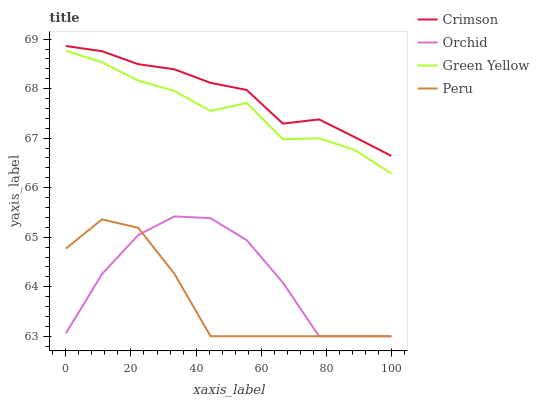Does Peru have the minimum area under the curve?
Answer yes or no. Yes. Does Crimson have the maximum area under the curve?
Answer yes or no. Yes. Does Green Yellow have the minimum area under the curve?
Answer yes or no. No. Does Green Yellow have the maximum area under the curve?
Answer yes or no. No. Is Crimson the smoothest?
Answer yes or no. Yes. Is Orchid the roughest?
Answer yes or no. Yes. Is Green Yellow the smoothest?
Answer yes or no. No. Is Green Yellow the roughest?
Answer yes or no. No. Does Green Yellow have the lowest value?
Answer yes or no. No. Does Crimson have the highest value?
Answer yes or no. Yes. Does Green Yellow have the highest value?
Answer yes or no. No. Is Green Yellow less than Crimson?
Answer yes or no. Yes. Is Crimson greater than Peru?
Answer yes or no. Yes. Does Peru intersect Orchid?
Answer yes or no. Yes. Is Peru less than Orchid?
Answer yes or no. No. Is Peru greater than Orchid?
Answer yes or no. No. Does Green Yellow intersect Crimson?
Answer yes or no. No. 